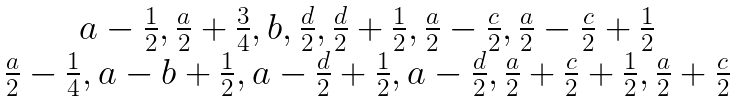Convert formula to latex. <formula><loc_0><loc_0><loc_500><loc_500>\begin{matrix} { a - \frac { 1 } { 2 } , \frac { a } { 2 } + \frac { 3 } { 4 } , b , \frac { d } { 2 } , \frac { d } { 2 } + \frac { 1 } { 2 } , \frac { a } { 2 } - \frac { c } { 2 } , \frac { a } { 2 } - \frac { c } { 2 } + \frac { 1 } { 2 } } \\ { \frac { a } { 2 } - \frac { 1 } { 4 } , a - b + \frac { 1 } { 2 } , a - \frac { d } { 2 } + \frac { 1 } { 2 } , a - \frac { d } { 2 } , \frac { a } { 2 } + \frac { c } { 2 } + \frac { 1 } { 2 } , \frac { a } { 2 } + \frac { c } { 2 } } \end{matrix}</formula> 